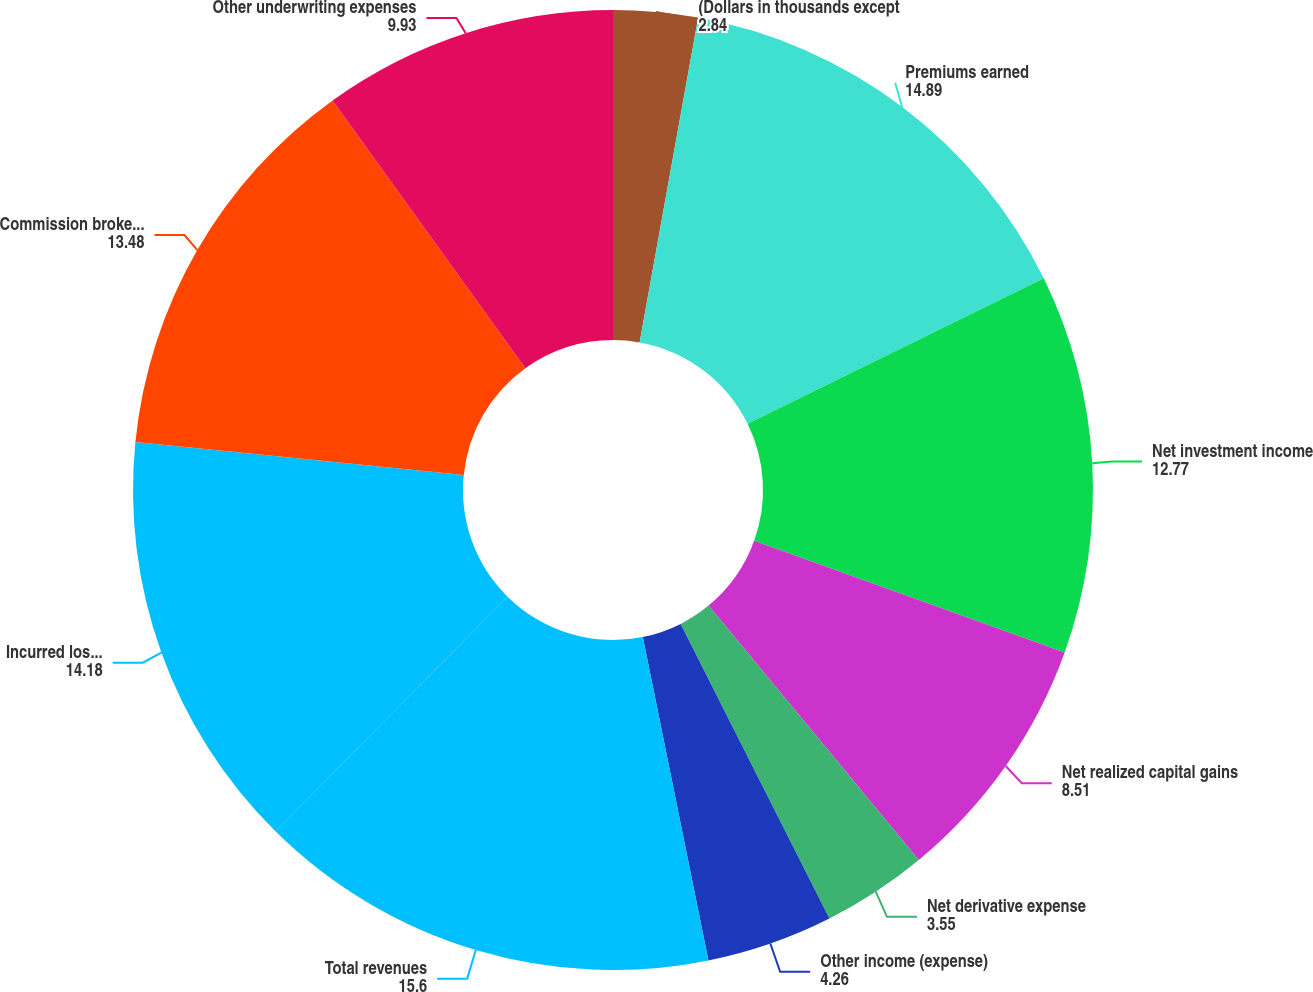Convert chart to OTSL. <chart><loc_0><loc_0><loc_500><loc_500><pie_chart><fcel>(Dollars in thousands except<fcel>Premiums earned<fcel>Net investment income<fcel>Net realized capital gains<fcel>Net derivative expense<fcel>Other income (expense)<fcel>Total revenues<fcel>Incurred losses and loss<fcel>Commission brokerage taxes and<fcel>Other underwriting expenses<nl><fcel>2.84%<fcel>14.89%<fcel>12.77%<fcel>8.51%<fcel>3.55%<fcel>4.26%<fcel>15.6%<fcel>14.18%<fcel>13.48%<fcel>9.93%<nl></chart> 